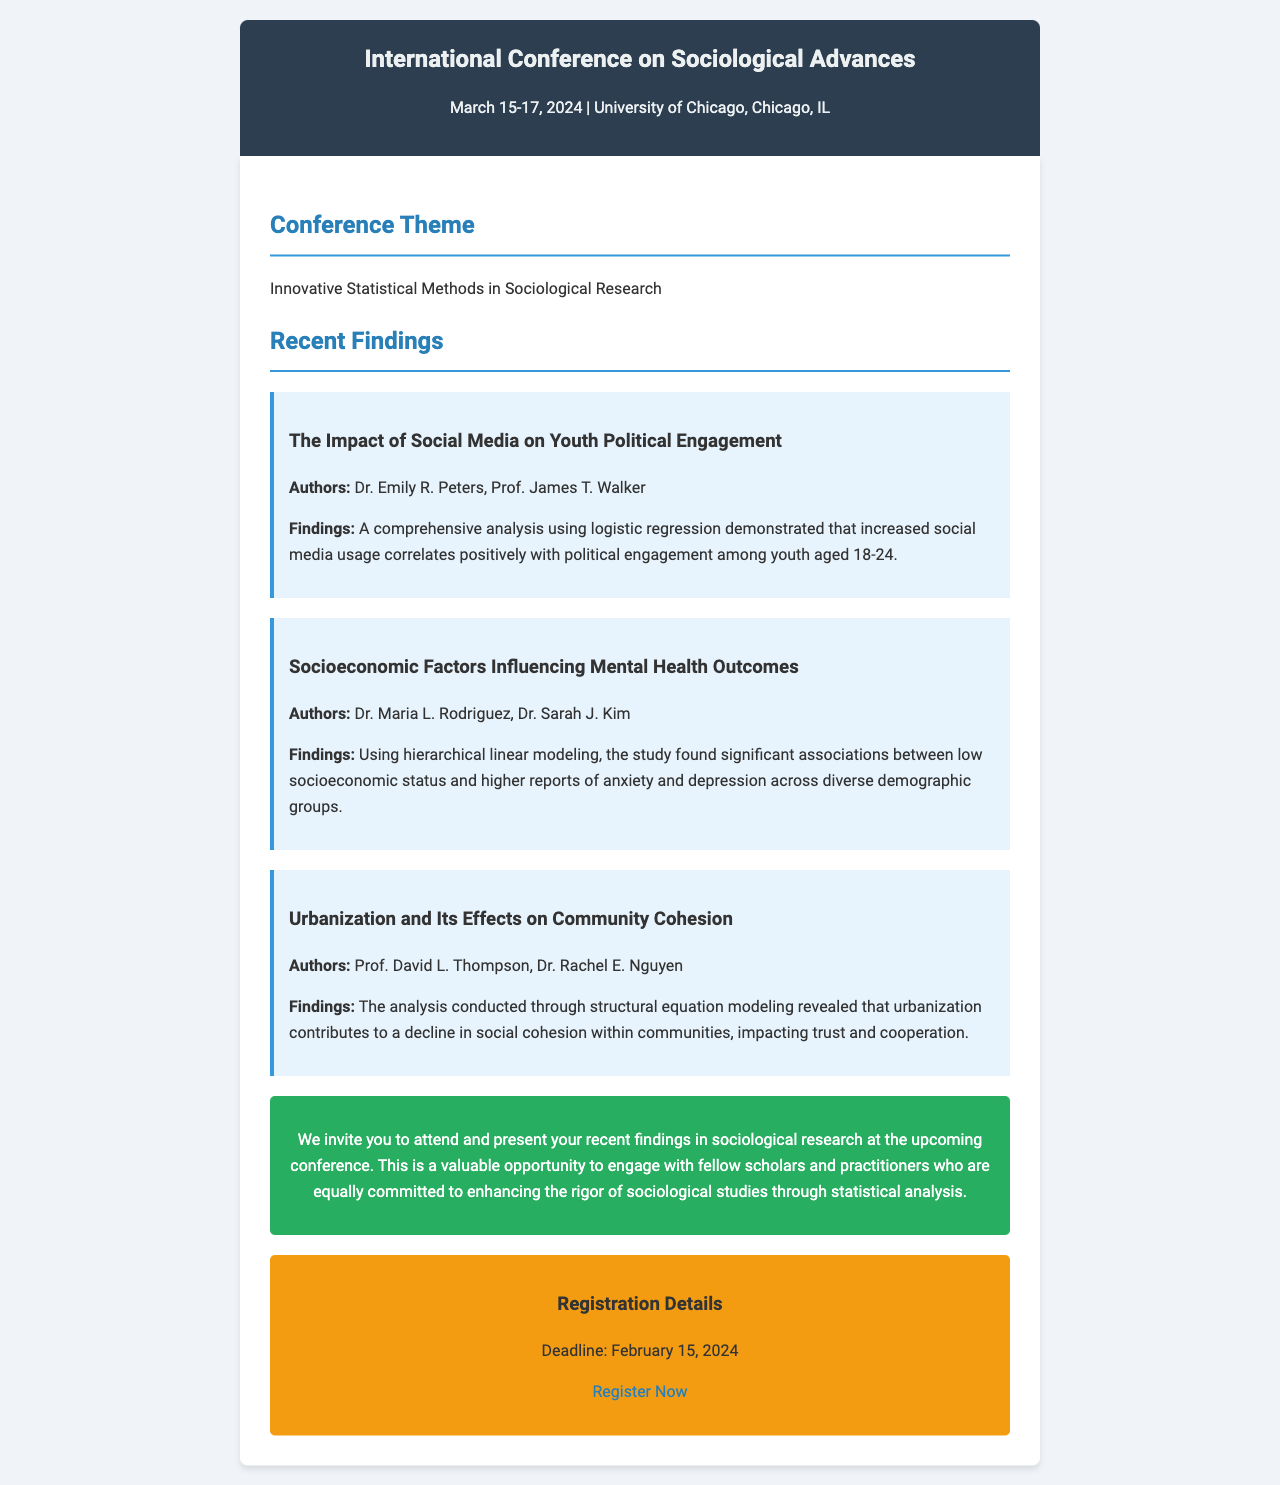What are the dates of the conference? The document specifies that the conference will take place from March 15-17, 2024.
Answer: March 15-17, 2024 Who is one of the authors of the study on social media and political engagement? The findings mention that Dr. Emily R. Peters is one of the authors of the specific study.
Answer: Dr. Emily R. Peters What statistical method was used in the socioeconomic factors study? The document indicates that hierarchical linear modeling was employed in this research.
Answer: Hierarchical linear modeling What is the conference theme? The document highlights that the theme of the conference is "Innovative Statistical Methods in Sociological Research."
Answer: Innovative Statistical Methods in Sociological Research What is the registration deadline? The document states that the registration deadline is February 15, 2024.
Answer: February 15, 2024 How many recent findings are presented in the document? The document presents three recent findings related to different sociological studies.
Answer: Three What is the location of the conference? The document mentions that the conference will be held at the University of Chicago, Chicago, IL.
Answer: University of Chicago, Chicago, IL What effect does urbanization have on community cohesion according to the findings? The findings indicate that urbanization contributes to a decline in social cohesion within communities.
Answer: Decline in social cohesion What does the CTA encourage participants to do? The Call to Action in the document invites attendees to present recent findings in sociological research.
Answer: Present your recent findings 